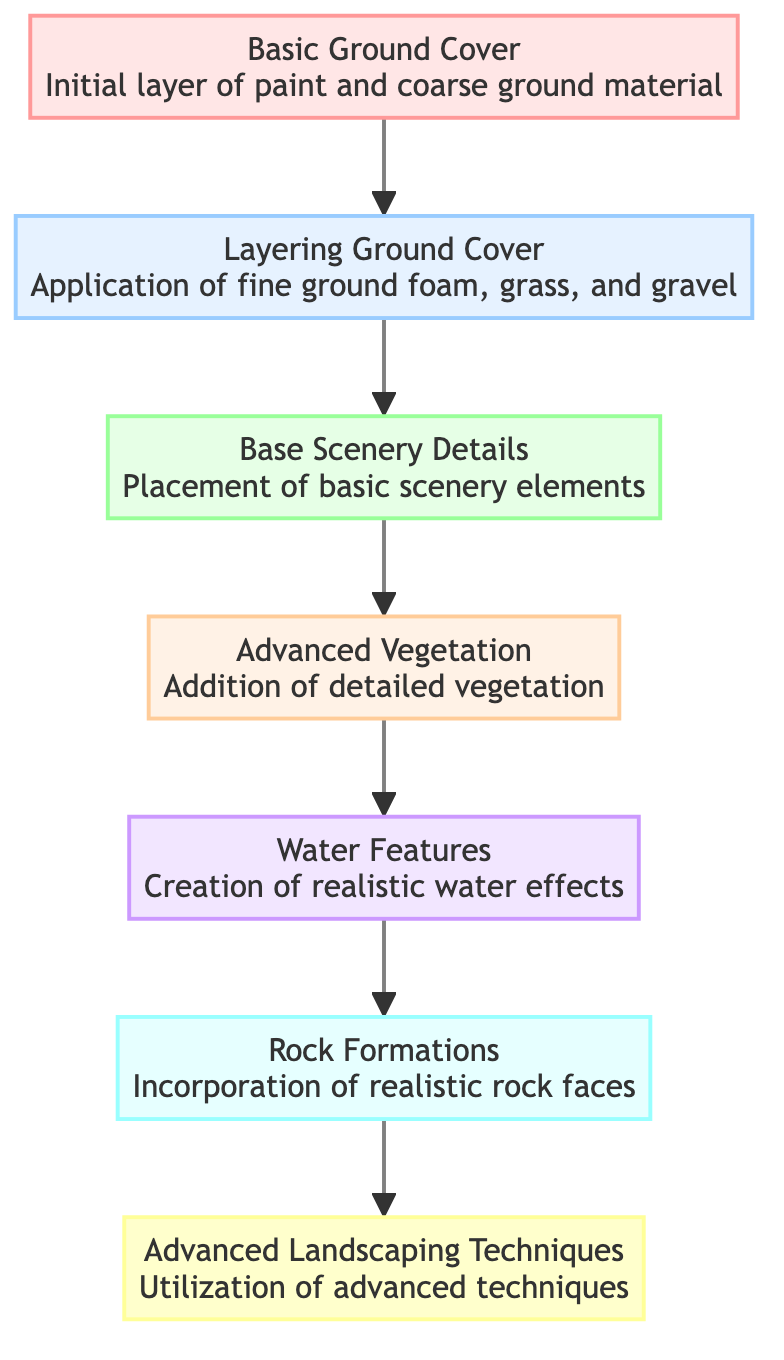What is the title of the diagram? The title of the diagram is displayed at the top and is "Evolution of Terrain and Scenery in Model Railroading."
Answer: Evolution of Terrain and Scenery in Model Railroading How many levels are there in the flow chart? By counting the number of levels in the flow chart, starting from "Basic Ground Cover" at level 1 to "Advanced Landscaping Techniques" at level 7, we find there are 7 levels total.
Answer: 7 What is the description of the third level? The description for the third level, titled "Base Scenery Details," is found below its title, providing the information that it involves the placement of basic scenery elements like trees, bushes, and simple structures.
Answer: Placement of basic scenery elements like trees, bushes, and simple structures Which level includes realistic water effects? Upon reviewing the levels, "Water Features" is identified at level 5, which specifically mentions the creation of realistic water effects such as rivers, lakes, and waterfalls.
Answer: Level 5 What comes immediately after “Layering Ground Cover” in the flow? Following "Layering Ground Cover" at level 2, the next level in the flow chart is "Base Scenery Details," indicating it is the subsequent step in the progression of terrain and scenery evolution.
Answer: Base Scenery Details What techniques are utilized in the most advanced level? In the final level titled "Advanced Landscaping Techniques," techniques mentioned include static grass applicators, weathering powders, and detailed cutout backdrops, making these the advanced methods used.
Answer: Static grass applicators, weathering powders, and detailed cutout backdrops What type of features does level 5 focus on? Reviewing level 5, it clearly focuses on "Water Features," which includes the creation of realistic effects like rivers, lakes, and waterfalls.
Answer: Realistic water effects Which level adds detailed vegetation? "Advanced Vegetation" is indicated as level 4 in the flow chart, which signifies the addition of detailed vegetation such as flowering plants, ivy, and varied tree types.
Answer: Level 4 